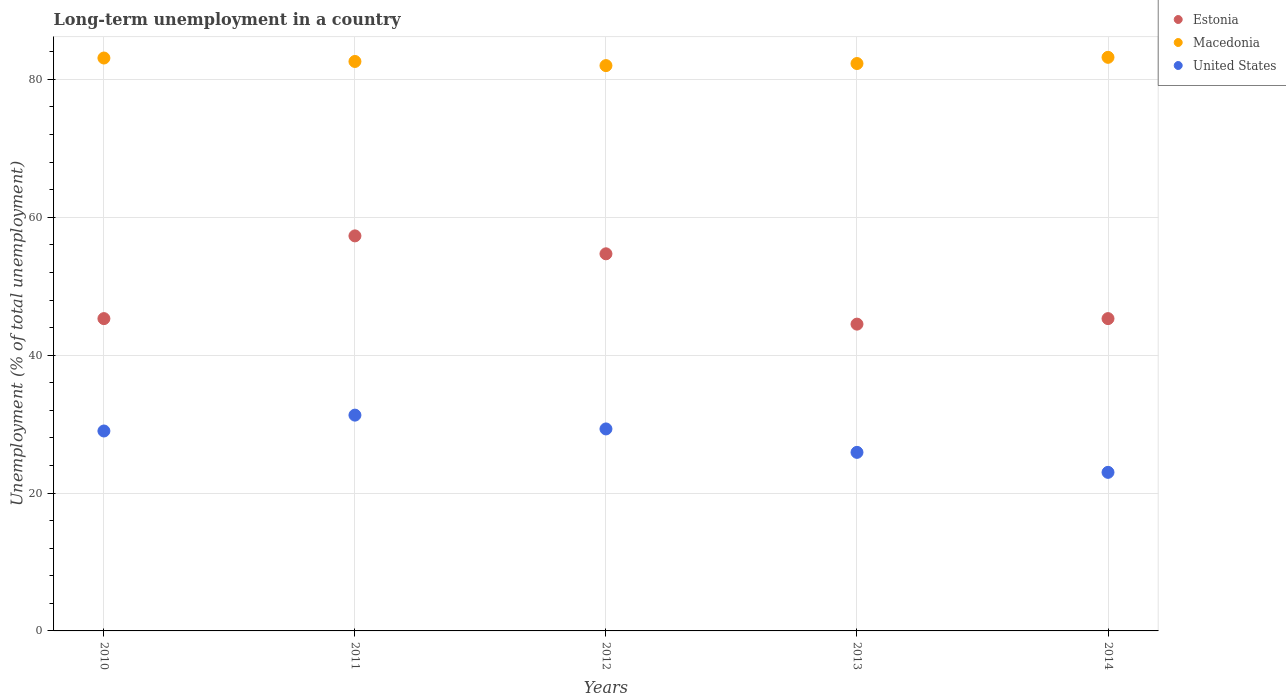How many different coloured dotlines are there?
Offer a very short reply. 3. What is the percentage of long-term unemployed population in Estonia in 2012?
Your answer should be very brief. 54.7. Across all years, what is the maximum percentage of long-term unemployed population in Macedonia?
Your response must be concise. 83.2. Across all years, what is the minimum percentage of long-term unemployed population in Estonia?
Ensure brevity in your answer.  44.5. In which year was the percentage of long-term unemployed population in Estonia minimum?
Your answer should be compact. 2013. What is the total percentage of long-term unemployed population in Estonia in the graph?
Provide a short and direct response. 247.1. What is the difference between the percentage of long-term unemployed population in Estonia in 2014 and the percentage of long-term unemployed population in Macedonia in 2010?
Make the answer very short. -37.8. What is the average percentage of long-term unemployed population in United States per year?
Your answer should be compact. 27.7. In the year 2011, what is the difference between the percentage of long-term unemployed population in Estonia and percentage of long-term unemployed population in United States?
Make the answer very short. 26. In how many years, is the percentage of long-term unemployed population in United States greater than 16 %?
Make the answer very short. 5. What is the ratio of the percentage of long-term unemployed population in Estonia in 2011 to that in 2012?
Provide a short and direct response. 1.05. Is the percentage of long-term unemployed population in United States in 2012 less than that in 2014?
Provide a short and direct response. No. What is the difference between the highest and the lowest percentage of long-term unemployed population in Estonia?
Provide a succinct answer. 12.8. Is it the case that in every year, the sum of the percentage of long-term unemployed population in United States and percentage of long-term unemployed population in Macedonia  is greater than the percentage of long-term unemployed population in Estonia?
Your response must be concise. Yes. Is the percentage of long-term unemployed population in United States strictly greater than the percentage of long-term unemployed population in Estonia over the years?
Provide a succinct answer. No. How many dotlines are there?
Ensure brevity in your answer.  3. How many years are there in the graph?
Your answer should be very brief. 5. What is the difference between two consecutive major ticks on the Y-axis?
Ensure brevity in your answer.  20. Does the graph contain any zero values?
Your answer should be compact. No. Does the graph contain grids?
Offer a terse response. Yes. How are the legend labels stacked?
Offer a very short reply. Vertical. What is the title of the graph?
Your answer should be very brief. Long-term unemployment in a country. Does "Switzerland" appear as one of the legend labels in the graph?
Give a very brief answer. No. What is the label or title of the X-axis?
Ensure brevity in your answer.  Years. What is the label or title of the Y-axis?
Ensure brevity in your answer.  Unemployment (% of total unemployment). What is the Unemployment (% of total unemployment) in Estonia in 2010?
Offer a terse response. 45.3. What is the Unemployment (% of total unemployment) in Macedonia in 2010?
Your answer should be very brief. 83.1. What is the Unemployment (% of total unemployment) of United States in 2010?
Provide a short and direct response. 29. What is the Unemployment (% of total unemployment) of Estonia in 2011?
Keep it short and to the point. 57.3. What is the Unemployment (% of total unemployment) in Macedonia in 2011?
Make the answer very short. 82.6. What is the Unemployment (% of total unemployment) in United States in 2011?
Your response must be concise. 31.3. What is the Unemployment (% of total unemployment) in Estonia in 2012?
Offer a terse response. 54.7. What is the Unemployment (% of total unemployment) of Macedonia in 2012?
Offer a terse response. 82. What is the Unemployment (% of total unemployment) in United States in 2012?
Give a very brief answer. 29.3. What is the Unemployment (% of total unemployment) of Estonia in 2013?
Keep it short and to the point. 44.5. What is the Unemployment (% of total unemployment) in Macedonia in 2013?
Keep it short and to the point. 82.3. What is the Unemployment (% of total unemployment) of United States in 2013?
Your answer should be compact. 25.9. What is the Unemployment (% of total unemployment) in Estonia in 2014?
Your response must be concise. 45.3. What is the Unemployment (% of total unemployment) of Macedonia in 2014?
Offer a very short reply. 83.2. What is the Unemployment (% of total unemployment) in United States in 2014?
Ensure brevity in your answer.  23. Across all years, what is the maximum Unemployment (% of total unemployment) in Estonia?
Your answer should be very brief. 57.3. Across all years, what is the maximum Unemployment (% of total unemployment) in Macedonia?
Offer a terse response. 83.2. Across all years, what is the maximum Unemployment (% of total unemployment) in United States?
Give a very brief answer. 31.3. Across all years, what is the minimum Unemployment (% of total unemployment) in Estonia?
Your response must be concise. 44.5. Across all years, what is the minimum Unemployment (% of total unemployment) of United States?
Your answer should be very brief. 23. What is the total Unemployment (% of total unemployment) in Estonia in the graph?
Keep it short and to the point. 247.1. What is the total Unemployment (% of total unemployment) in Macedonia in the graph?
Your response must be concise. 413.2. What is the total Unemployment (% of total unemployment) in United States in the graph?
Your response must be concise. 138.5. What is the difference between the Unemployment (% of total unemployment) in Estonia in 2010 and that in 2011?
Your response must be concise. -12. What is the difference between the Unemployment (% of total unemployment) of Macedonia in 2010 and that in 2011?
Give a very brief answer. 0.5. What is the difference between the Unemployment (% of total unemployment) in Estonia in 2010 and that in 2012?
Give a very brief answer. -9.4. What is the difference between the Unemployment (% of total unemployment) of Macedonia in 2010 and that in 2012?
Make the answer very short. 1.1. What is the difference between the Unemployment (% of total unemployment) in United States in 2010 and that in 2012?
Keep it short and to the point. -0.3. What is the difference between the Unemployment (% of total unemployment) in Estonia in 2010 and that in 2013?
Give a very brief answer. 0.8. What is the difference between the Unemployment (% of total unemployment) in Macedonia in 2010 and that in 2014?
Your response must be concise. -0.1. What is the difference between the Unemployment (% of total unemployment) in United States in 2010 and that in 2014?
Provide a succinct answer. 6. What is the difference between the Unemployment (% of total unemployment) of Macedonia in 2011 and that in 2012?
Offer a very short reply. 0.6. What is the difference between the Unemployment (% of total unemployment) in United States in 2011 and that in 2012?
Give a very brief answer. 2. What is the difference between the Unemployment (% of total unemployment) of Estonia in 2011 and that in 2013?
Give a very brief answer. 12.8. What is the difference between the Unemployment (% of total unemployment) of Macedonia in 2011 and that in 2013?
Keep it short and to the point. 0.3. What is the difference between the Unemployment (% of total unemployment) of Estonia in 2011 and that in 2014?
Provide a succinct answer. 12. What is the difference between the Unemployment (% of total unemployment) in Macedonia in 2011 and that in 2014?
Your answer should be very brief. -0.6. What is the difference between the Unemployment (% of total unemployment) in Estonia in 2012 and that in 2013?
Keep it short and to the point. 10.2. What is the difference between the Unemployment (% of total unemployment) in Estonia in 2012 and that in 2014?
Provide a short and direct response. 9.4. What is the difference between the Unemployment (% of total unemployment) of Estonia in 2013 and that in 2014?
Ensure brevity in your answer.  -0.8. What is the difference between the Unemployment (% of total unemployment) of United States in 2013 and that in 2014?
Provide a succinct answer. 2.9. What is the difference between the Unemployment (% of total unemployment) in Estonia in 2010 and the Unemployment (% of total unemployment) in Macedonia in 2011?
Offer a very short reply. -37.3. What is the difference between the Unemployment (% of total unemployment) in Estonia in 2010 and the Unemployment (% of total unemployment) in United States in 2011?
Give a very brief answer. 14. What is the difference between the Unemployment (% of total unemployment) in Macedonia in 2010 and the Unemployment (% of total unemployment) in United States in 2011?
Offer a terse response. 51.8. What is the difference between the Unemployment (% of total unemployment) of Estonia in 2010 and the Unemployment (% of total unemployment) of Macedonia in 2012?
Make the answer very short. -36.7. What is the difference between the Unemployment (% of total unemployment) of Estonia in 2010 and the Unemployment (% of total unemployment) of United States in 2012?
Your response must be concise. 16. What is the difference between the Unemployment (% of total unemployment) of Macedonia in 2010 and the Unemployment (% of total unemployment) of United States in 2012?
Give a very brief answer. 53.8. What is the difference between the Unemployment (% of total unemployment) of Estonia in 2010 and the Unemployment (% of total unemployment) of Macedonia in 2013?
Your response must be concise. -37. What is the difference between the Unemployment (% of total unemployment) in Macedonia in 2010 and the Unemployment (% of total unemployment) in United States in 2013?
Provide a succinct answer. 57.2. What is the difference between the Unemployment (% of total unemployment) of Estonia in 2010 and the Unemployment (% of total unemployment) of Macedonia in 2014?
Provide a succinct answer. -37.9. What is the difference between the Unemployment (% of total unemployment) in Estonia in 2010 and the Unemployment (% of total unemployment) in United States in 2014?
Offer a very short reply. 22.3. What is the difference between the Unemployment (% of total unemployment) in Macedonia in 2010 and the Unemployment (% of total unemployment) in United States in 2014?
Keep it short and to the point. 60.1. What is the difference between the Unemployment (% of total unemployment) in Estonia in 2011 and the Unemployment (% of total unemployment) in Macedonia in 2012?
Your response must be concise. -24.7. What is the difference between the Unemployment (% of total unemployment) of Macedonia in 2011 and the Unemployment (% of total unemployment) of United States in 2012?
Keep it short and to the point. 53.3. What is the difference between the Unemployment (% of total unemployment) in Estonia in 2011 and the Unemployment (% of total unemployment) in Macedonia in 2013?
Make the answer very short. -25. What is the difference between the Unemployment (% of total unemployment) of Estonia in 2011 and the Unemployment (% of total unemployment) of United States in 2013?
Your answer should be very brief. 31.4. What is the difference between the Unemployment (% of total unemployment) of Macedonia in 2011 and the Unemployment (% of total unemployment) of United States in 2013?
Your response must be concise. 56.7. What is the difference between the Unemployment (% of total unemployment) in Estonia in 2011 and the Unemployment (% of total unemployment) in Macedonia in 2014?
Keep it short and to the point. -25.9. What is the difference between the Unemployment (% of total unemployment) in Estonia in 2011 and the Unemployment (% of total unemployment) in United States in 2014?
Provide a succinct answer. 34.3. What is the difference between the Unemployment (% of total unemployment) in Macedonia in 2011 and the Unemployment (% of total unemployment) in United States in 2014?
Keep it short and to the point. 59.6. What is the difference between the Unemployment (% of total unemployment) in Estonia in 2012 and the Unemployment (% of total unemployment) in Macedonia in 2013?
Make the answer very short. -27.6. What is the difference between the Unemployment (% of total unemployment) in Estonia in 2012 and the Unemployment (% of total unemployment) in United States in 2013?
Your response must be concise. 28.8. What is the difference between the Unemployment (% of total unemployment) of Macedonia in 2012 and the Unemployment (% of total unemployment) of United States in 2013?
Your answer should be very brief. 56.1. What is the difference between the Unemployment (% of total unemployment) in Estonia in 2012 and the Unemployment (% of total unemployment) in Macedonia in 2014?
Provide a short and direct response. -28.5. What is the difference between the Unemployment (% of total unemployment) in Estonia in 2012 and the Unemployment (% of total unemployment) in United States in 2014?
Provide a short and direct response. 31.7. What is the difference between the Unemployment (% of total unemployment) in Macedonia in 2012 and the Unemployment (% of total unemployment) in United States in 2014?
Your response must be concise. 59. What is the difference between the Unemployment (% of total unemployment) of Estonia in 2013 and the Unemployment (% of total unemployment) of Macedonia in 2014?
Keep it short and to the point. -38.7. What is the difference between the Unemployment (% of total unemployment) in Estonia in 2013 and the Unemployment (% of total unemployment) in United States in 2014?
Provide a succinct answer. 21.5. What is the difference between the Unemployment (% of total unemployment) of Macedonia in 2013 and the Unemployment (% of total unemployment) of United States in 2014?
Provide a succinct answer. 59.3. What is the average Unemployment (% of total unemployment) of Estonia per year?
Your response must be concise. 49.42. What is the average Unemployment (% of total unemployment) in Macedonia per year?
Your answer should be very brief. 82.64. What is the average Unemployment (% of total unemployment) in United States per year?
Your answer should be very brief. 27.7. In the year 2010, what is the difference between the Unemployment (% of total unemployment) in Estonia and Unemployment (% of total unemployment) in Macedonia?
Offer a very short reply. -37.8. In the year 2010, what is the difference between the Unemployment (% of total unemployment) in Estonia and Unemployment (% of total unemployment) in United States?
Ensure brevity in your answer.  16.3. In the year 2010, what is the difference between the Unemployment (% of total unemployment) of Macedonia and Unemployment (% of total unemployment) of United States?
Ensure brevity in your answer.  54.1. In the year 2011, what is the difference between the Unemployment (% of total unemployment) of Estonia and Unemployment (% of total unemployment) of Macedonia?
Give a very brief answer. -25.3. In the year 2011, what is the difference between the Unemployment (% of total unemployment) in Macedonia and Unemployment (% of total unemployment) in United States?
Ensure brevity in your answer.  51.3. In the year 2012, what is the difference between the Unemployment (% of total unemployment) of Estonia and Unemployment (% of total unemployment) of Macedonia?
Keep it short and to the point. -27.3. In the year 2012, what is the difference between the Unemployment (% of total unemployment) of Estonia and Unemployment (% of total unemployment) of United States?
Provide a succinct answer. 25.4. In the year 2012, what is the difference between the Unemployment (% of total unemployment) of Macedonia and Unemployment (% of total unemployment) of United States?
Offer a terse response. 52.7. In the year 2013, what is the difference between the Unemployment (% of total unemployment) of Estonia and Unemployment (% of total unemployment) of Macedonia?
Your answer should be very brief. -37.8. In the year 2013, what is the difference between the Unemployment (% of total unemployment) in Estonia and Unemployment (% of total unemployment) in United States?
Make the answer very short. 18.6. In the year 2013, what is the difference between the Unemployment (% of total unemployment) of Macedonia and Unemployment (% of total unemployment) of United States?
Give a very brief answer. 56.4. In the year 2014, what is the difference between the Unemployment (% of total unemployment) of Estonia and Unemployment (% of total unemployment) of Macedonia?
Provide a succinct answer. -37.9. In the year 2014, what is the difference between the Unemployment (% of total unemployment) in Estonia and Unemployment (% of total unemployment) in United States?
Provide a succinct answer. 22.3. In the year 2014, what is the difference between the Unemployment (% of total unemployment) in Macedonia and Unemployment (% of total unemployment) in United States?
Keep it short and to the point. 60.2. What is the ratio of the Unemployment (% of total unemployment) in Estonia in 2010 to that in 2011?
Make the answer very short. 0.79. What is the ratio of the Unemployment (% of total unemployment) of Macedonia in 2010 to that in 2011?
Ensure brevity in your answer.  1.01. What is the ratio of the Unemployment (% of total unemployment) of United States in 2010 to that in 2011?
Offer a terse response. 0.93. What is the ratio of the Unemployment (% of total unemployment) of Estonia in 2010 to that in 2012?
Your answer should be compact. 0.83. What is the ratio of the Unemployment (% of total unemployment) in Macedonia in 2010 to that in 2012?
Your answer should be very brief. 1.01. What is the ratio of the Unemployment (% of total unemployment) of Estonia in 2010 to that in 2013?
Offer a terse response. 1.02. What is the ratio of the Unemployment (% of total unemployment) in Macedonia in 2010 to that in 2013?
Provide a succinct answer. 1.01. What is the ratio of the Unemployment (% of total unemployment) in United States in 2010 to that in 2013?
Keep it short and to the point. 1.12. What is the ratio of the Unemployment (% of total unemployment) of Estonia in 2010 to that in 2014?
Provide a short and direct response. 1. What is the ratio of the Unemployment (% of total unemployment) of Macedonia in 2010 to that in 2014?
Give a very brief answer. 1. What is the ratio of the Unemployment (% of total unemployment) in United States in 2010 to that in 2014?
Keep it short and to the point. 1.26. What is the ratio of the Unemployment (% of total unemployment) of Estonia in 2011 to that in 2012?
Offer a terse response. 1.05. What is the ratio of the Unemployment (% of total unemployment) of Macedonia in 2011 to that in 2012?
Provide a succinct answer. 1.01. What is the ratio of the Unemployment (% of total unemployment) of United States in 2011 to that in 2012?
Make the answer very short. 1.07. What is the ratio of the Unemployment (% of total unemployment) of Estonia in 2011 to that in 2013?
Your answer should be compact. 1.29. What is the ratio of the Unemployment (% of total unemployment) in United States in 2011 to that in 2013?
Ensure brevity in your answer.  1.21. What is the ratio of the Unemployment (% of total unemployment) in Estonia in 2011 to that in 2014?
Your answer should be compact. 1.26. What is the ratio of the Unemployment (% of total unemployment) of Macedonia in 2011 to that in 2014?
Offer a terse response. 0.99. What is the ratio of the Unemployment (% of total unemployment) of United States in 2011 to that in 2014?
Offer a very short reply. 1.36. What is the ratio of the Unemployment (% of total unemployment) of Estonia in 2012 to that in 2013?
Provide a succinct answer. 1.23. What is the ratio of the Unemployment (% of total unemployment) in United States in 2012 to that in 2013?
Offer a terse response. 1.13. What is the ratio of the Unemployment (% of total unemployment) in Estonia in 2012 to that in 2014?
Your answer should be compact. 1.21. What is the ratio of the Unemployment (% of total unemployment) of Macedonia in 2012 to that in 2014?
Provide a short and direct response. 0.99. What is the ratio of the Unemployment (% of total unemployment) in United States in 2012 to that in 2014?
Ensure brevity in your answer.  1.27. What is the ratio of the Unemployment (% of total unemployment) of Estonia in 2013 to that in 2014?
Your answer should be very brief. 0.98. What is the ratio of the Unemployment (% of total unemployment) in United States in 2013 to that in 2014?
Offer a terse response. 1.13. What is the difference between the highest and the second highest Unemployment (% of total unemployment) of Macedonia?
Offer a very short reply. 0.1. What is the difference between the highest and the second highest Unemployment (% of total unemployment) in United States?
Provide a short and direct response. 2. What is the difference between the highest and the lowest Unemployment (% of total unemployment) of United States?
Your answer should be very brief. 8.3. 